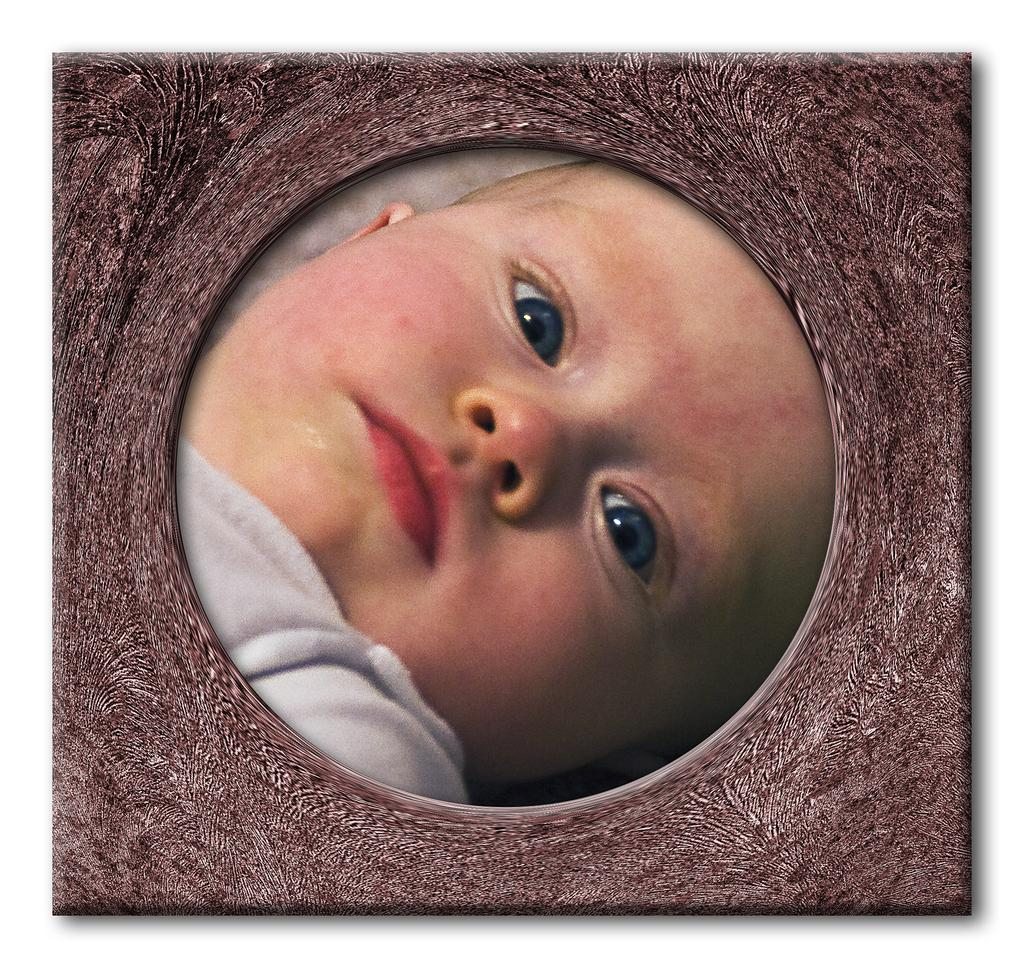What is the main subject of the image? The main subject of the image is a child. What is the child wearing in the image? The child is wearing a white dress. What type of comb is the child using to attack the coach in the image? There is no comb, attack, or coach present in the image. 